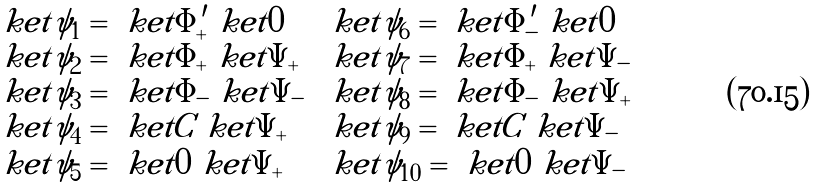Convert formula to latex. <formula><loc_0><loc_0><loc_500><loc_500>\begin{array} { l l } \ k e t { \psi _ { 1 } } = \ k e t { \Phi ^ { \prime } _ { + } } \ k e t { 0 } & \ k e t { \psi _ { 6 } } = \ k e t { \Phi ^ { \prime } _ { - } } \ k e t { 0 } \\ \ k e t { \psi _ { 2 } } = \ k e t { \Phi _ { + } } \ k e t { \Psi _ { + } } & \ k e t { \psi _ { 7 } } = \ k e t { \Phi _ { + } } \ k e t { \Psi _ { - } } \\ \ k e t { \psi _ { 3 } } = \ k e t { \Phi _ { - } } \ k e t { \Psi _ { - } } & \ k e t { \psi _ { 8 } } = \ k e t { \Phi _ { - } } \ k e t { \Psi _ { + } } \\ \ k e t { \psi _ { 4 } } = \ k e t { C } \ k e t { \Psi _ { + } } & \ k e t { \psi _ { 9 } } = \ k e t { C } \ k e t { \Psi _ { - } } \\ \ k e t { \psi _ { 5 } } = \ k e t { 0 } \ k e t { \Psi _ { + } } & \ k e t { \psi _ { 1 0 } } = \ k e t { 0 } \ k e t { \Psi _ { - } } \end{array}</formula> 